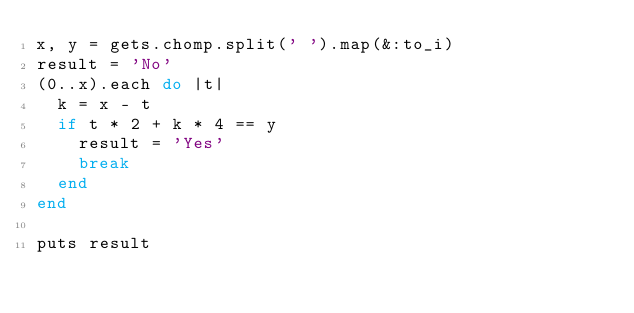Convert code to text. <code><loc_0><loc_0><loc_500><loc_500><_Ruby_>x, y = gets.chomp.split(' ').map(&:to_i)
result = 'No'
(0..x).each do |t|
  k = x - t
  if t * 2 + k * 4 == y
    result = 'Yes'
    break
  end
end

puts result</code> 